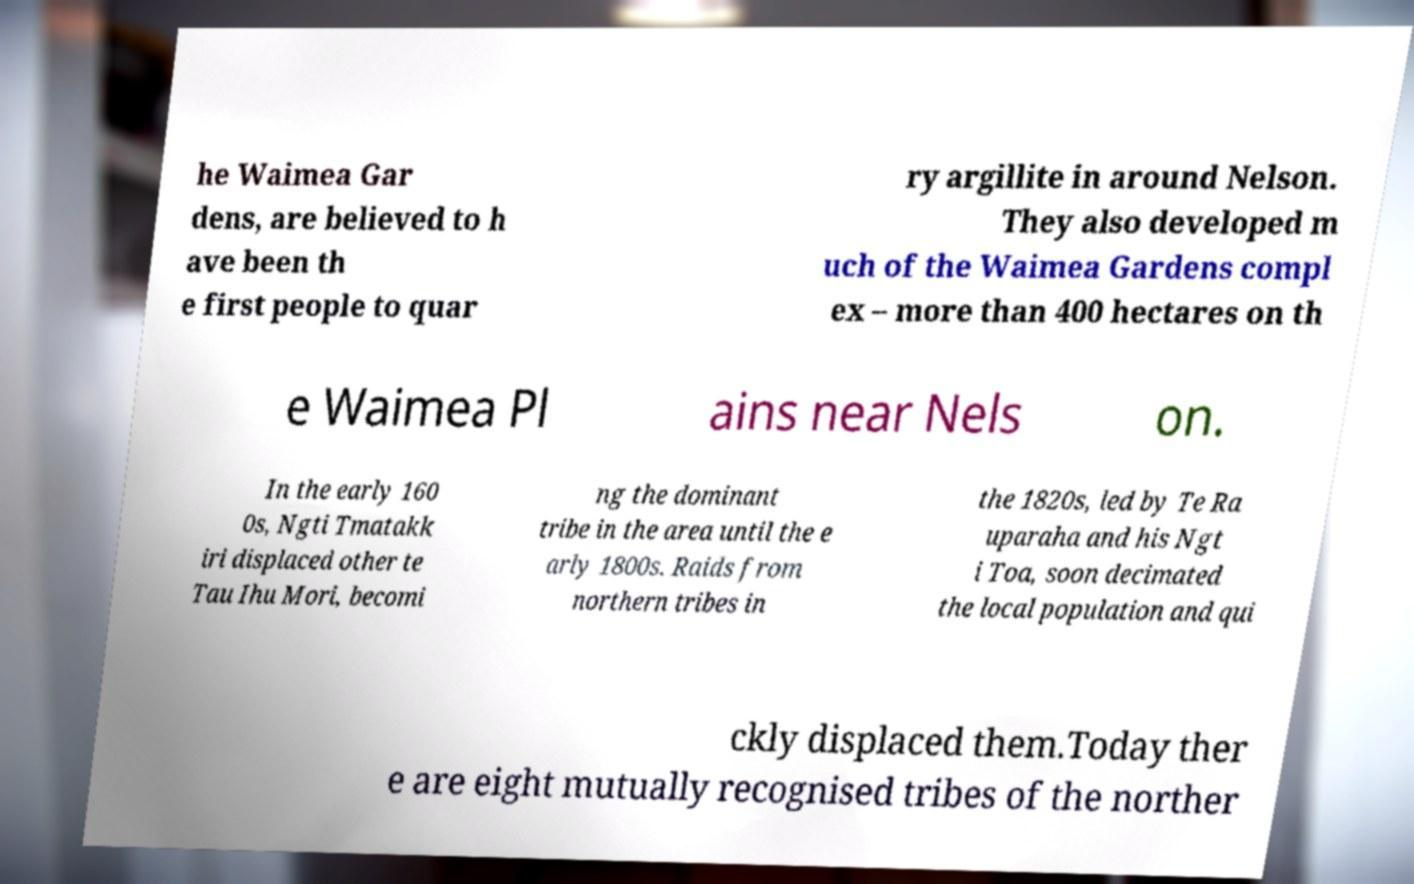Could you assist in decoding the text presented in this image and type it out clearly? he Waimea Gar dens, are believed to h ave been th e first people to quar ry argillite in around Nelson. They also developed m uch of the Waimea Gardens compl ex – more than 400 hectares on th e Waimea Pl ains near Nels on. In the early 160 0s, Ngti Tmatakk iri displaced other te Tau Ihu Mori, becomi ng the dominant tribe in the area until the e arly 1800s. Raids from northern tribes in the 1820s, led by Te Ra uparaha and his Ngt i Toa, soon decimated the local population and qui ckly displaced them.Today ther e are eight mutually recognised tribes of the norther 